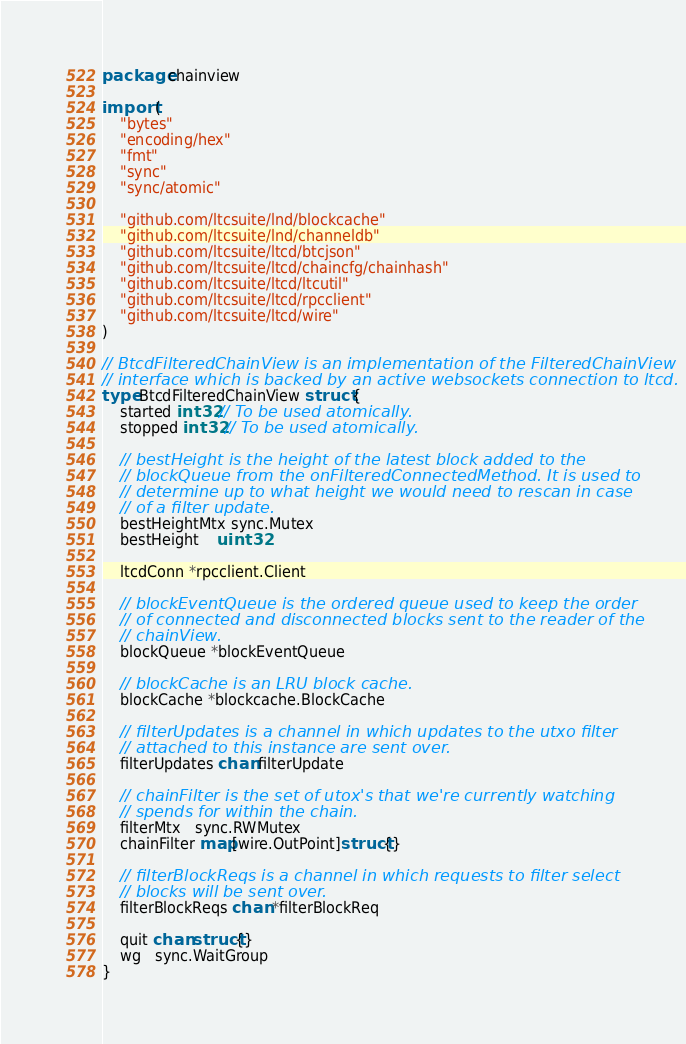Convert code to text. <code><loc_0><loc_0><loc_500><loc_500><_Go_>package chainview

import (
	"bytes"
	"encoding/hex"
	"fmt"
	"sync"
	"sync/atomic"

	"github.com/ltcsuite/lnd/blockcache"
	"github.com/ltcsuite/lnd/channeldb"
	"github.com/ltcsuite/ltcd/btcjson"
	"github.com/ltcsuite/ltcd/chaincfg/chainhash"
	"github.com/ltcsuite/ltcd/ltcutil"
	"github.com/ltcsuite/ltcd/rpcclient"
	"github.com/ltcsuite/ltcd/wire"
)

// BtcdFilteredChainView is an implementation of the FilteredChainView
// interface which is backed by an active websockets connection to ltcd.
type BtcdFilteredChainView struct {
	started int32 // To be used atomically.
	stopped int32 // To be used atomically.

	// bestHeight is the height of the latest block added to the
	// blockQueue from the onFilteredConnectedMethod. It is used to
	// determine up to what height we would need to rescan in case
	// of a filter update.
	bestHeightMtx sync.Mutex
	bestHeight    uint32

	ltcdConn *rpcclient.Client

	// blockEventQueue is the ordered queue used to keep the order
	// of connected and disconnected blocks sent to the reader of the
	// chainView.
	blockQueue *blockEventQueue

	// blockCache is an LRU block cache.
	blockCache *blockcache.BlockCache

	// filterUpdates is a channel in which updates to the utxo filter
	// attached to this instance are sent over.
	filterUpdates chan filterUpdate

	// chainFilter is the set of utox's that we're currently watching
	// spends for within the chain.
	filterMtx   sync.RWMutex
	chainFilter map[wire.OutPoint]struct{}

	// filterBlockReqs is a channel in which requests to filter select
	// blocks will be sent over.
	filterBlockReqs chan *filterBlockReq

	quit chan struct{}
	wg   sync.WaitGroup
}
</code> 